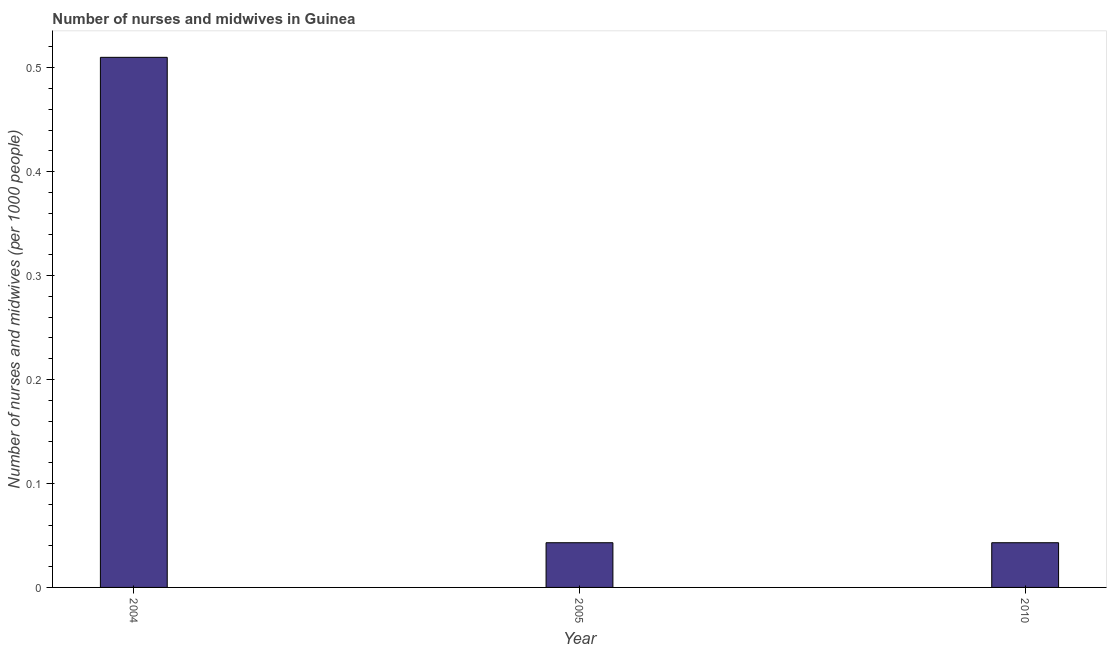What is the title of the graph?
Make the answer very short. Number of nurses and midwives in Guinea. What is the label or title of the Y-axis?
Your response must be concise. Number of nurses and midwives (per 1000 people). What is the number of nurses and midwives in 2005?
Give a very brief answer. 0.04. Across all years, what is the maximum number of nurses and midwives?
Provide a succinct answer. 0.51. Across all years, what is the minimum number of nurses and midwives?
Your answer should be very brief. 0.04. In which year was the number of nurses and midwives maximum?
Offer a very short reply. 2004. What is the sum of the number of nurses and midwives?
Your answer should be compact. 0.6. What is the difference between the number of nurses and midwives in 2005 and 2010?
Keep it short and to the point. 0. What is the average number of nurses and midwives per year?
Give a very brief answer. 0.2. What is the median number of nurses and midwives?
Your answer should be very brief. 0.04. Do a majority of the years between 2010 and 2005 (inclusive) have number of nurses and midwives greater than 0.4 ?
Your answer should be compact. No. What is the ratio of the number of nurses and midwives in 2005 to that in 2010?
Ensure brevity in your answer.  1. Is the number of nurses and midwives in 2004 less than that in 2010?
Offer a terse response. No. What is the difference between the highest and the second highest number of nurses and midwives?
Provide a short and direct response. 0.47. Is the sum of the number of nurses and midwives in 2004 and 2010 greater than the maximum number of nurses and midwives across all years?
Your response must be concise. Yes. What is the difference between the highest and the lowest number of nurses and midwives?
Offer a terse response. 0.47. In how many years, is the number of nurses and midwives greater than the average number of nurses and midwives taken over all years?
Provide a succinct answer. 1. How many years are there in the graph?
Offer a very short reply. 3. What is the difference between two consecutive major ticks on the Y-axis?
Offer a terse response. 0.1. Are the values on the major ticks of Y-axis written in scientific E-notation?
Provide a short and direct response. No. What is the Number of nurses and midwives (per 1000 people) in 2004?
Your answer should be compact. 0.51. What is the Number of nurses and midwives (per 1000 people) in 2005?
Offer a very short reply. 0.04. What is the Number of nurses and midwives (per 1000 people) of 2010?
Your answer should be very brief. 0.04. What is the difference between the Number of nurses and midwives (per 1000 people) in 2004 and 2005?
Give a very brief answer. 0.47. What is the difference between the Number of nurses and midwives (per 1000 people) in 2004 and 2010?
Give a very brief answer. 0.47. What is the ratio of the Number of nurses and midwives (per 1000 people) in 2004 to that in 2005?
Provide a short and direct response. 11.86. What is the ratio of the Number of nurses and midwives (per 1000 people) in 2004 to that in 2010?
Provide a short and direct response. 11.86. 